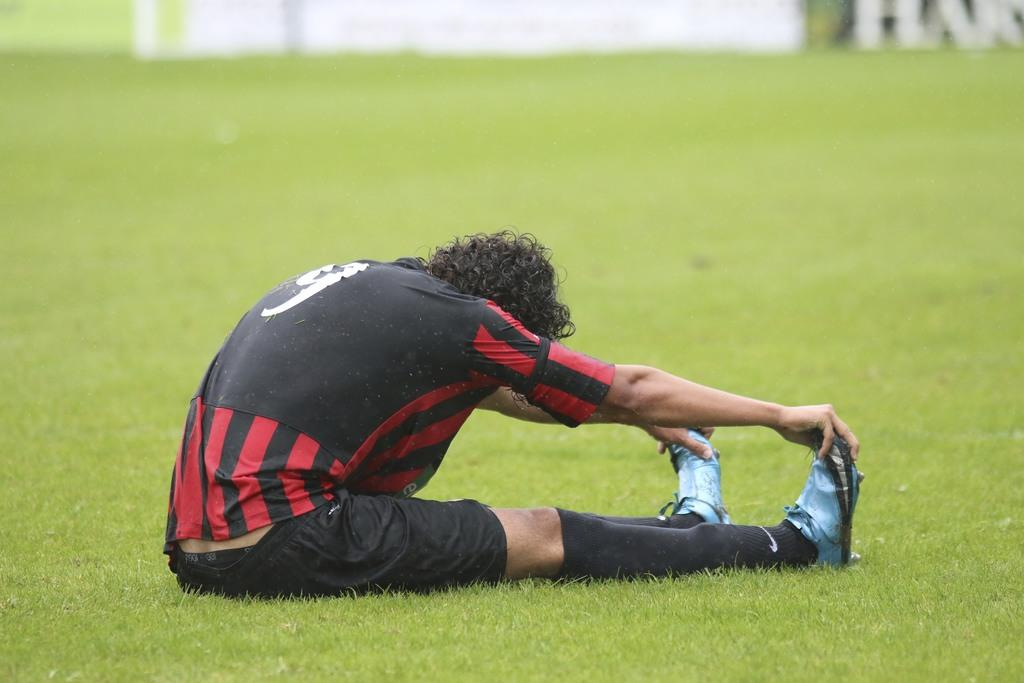What is the person in the image doing? The person is sitting on the grass in the image. Can you describe the object at the top of the image? Unfortunately, the provided facts do not give any information about the object at the top of the image. What type of engine is visible in the image? There is no engine present in the image. What part of the person's body is facing the front in the image? The provided facts do not give any information about the person's body position or orientation. 